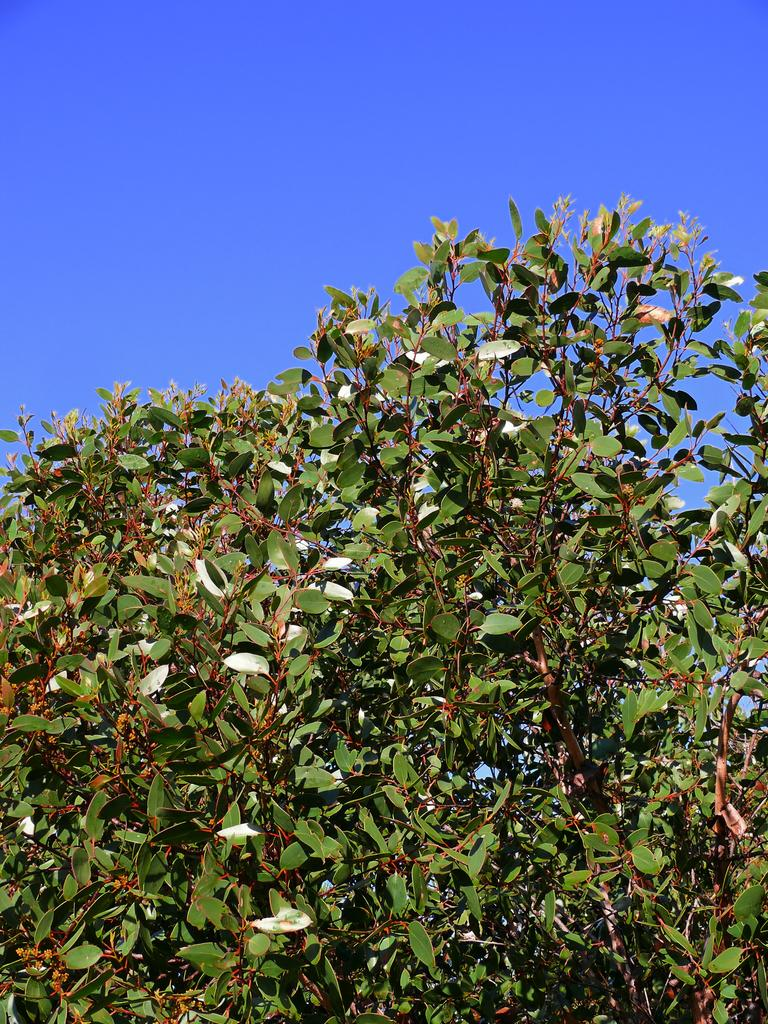What type of living organisms can be seen in the image? Plants can be seen in the image. What is the color of the plants in the image? The plants are green in color. What part of the natural environment is visible in the image? The sky is visible in the image. What type of circle can be seen drawn with chalk in the image? There is no circle or chalk present in the image; it features plants and the sky. How old is the baby in the image? There is no baby present in the image. 